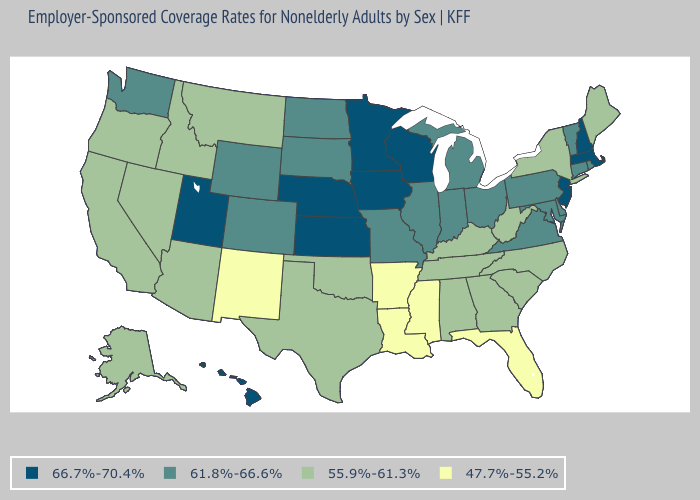What is the value of Minnesota?
Short answer required. 66.7%-70.4%. Does Rhode Island have a lower value than Massachusetts?
Be succinct. Yes. Is the legend a continuous bar?
Quick response, please. No. What is the value of Utah?
Quick response, please. 66.7%-70.4%. Among the states that border New Mexico , does Utah have the highest value?
Quick response, please. Yes. What is the value of Nebraska?
Write a very short answer. 66.7%-70.4%. Does Ohio have a lower value than South Dakota?
Quick response, please. No. Does Louisiana have the lowest value in the USA?
Short answer required. Yes. Does the first symbol in the legend represent the smallest category?
Give a very brief answer. No. What is the value of Vermont?
Write a very short answer. 61.8%-66.6%. Does Texas have a lower value than Virginia?
Answer briefly. Yes. Among the states that border New Jersey , which have the highest value?
Keep it brief. Delaware, Pennsylvania. What is the value of Hawaii?
Quick response, please. 66.7%-70.4%. What is the lowest value in the South?
Write a very short answer. 47.7%-55.2%. Which states have the highest value in the USA?
Quick response, please. Hawaii, Iowa, Kansas, Massachusetts, Minnesota, Nebraska, New Hampshire, New Jersey, Utah, Wisconsin. 